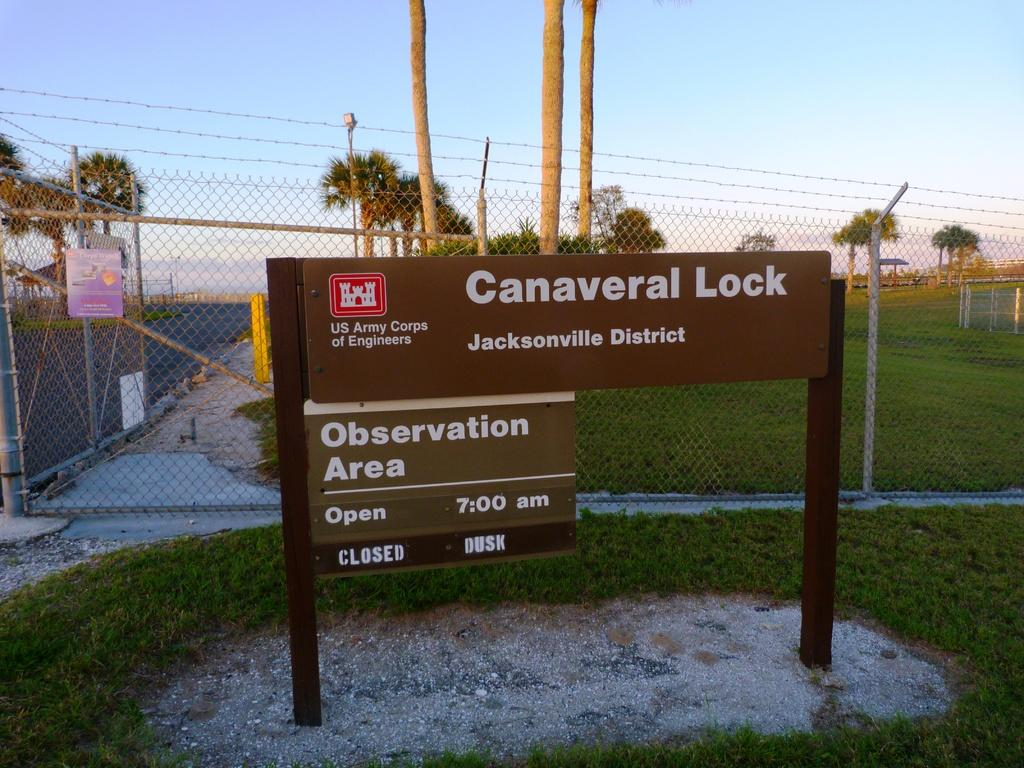What is attached to the pole in the image? There are boards attached to a pole in the image. What can be seen in the background of the image? There is fencing and green trees visible in the background of the image. What type of structure is present in the image? There is a light pole in the image. What is the color of the sky in the image? The sky is blue and white in color. What type of news can be heard coming from the faucet in the image? There is no faucet present in the image, and therefore no news can be heard coming from it. 